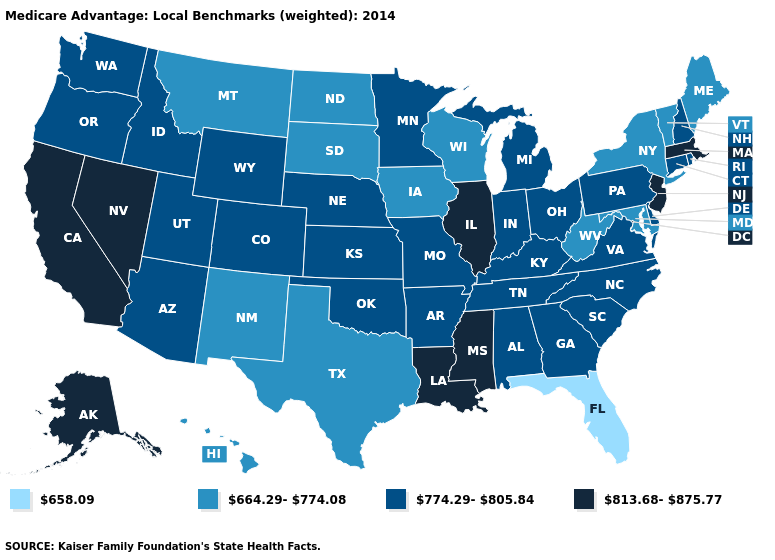Which states have the lowest value in the Northeast?
Write a very short answer. Maine, New York, Vermont. What is the value of Nevada?
Short answer required. 813.68-875.77. Which states have the lowest value in the USA?
Quick response, please. Florida. How many symbols are there in the legend?
Quick response, please. 4. What is the highest value in states that border New Mexico?
Short answer required. 774.29-805.84. What is the lowest value in states that border Tennessee?
Short answer required. 774.29-805.84. Does the map have missing data?
Keep it brief. No. Which states have the lowest value in the Northeast?
Short answer required. Maine, New York, Vermont. Name the states that have a value in the range 658.09?
Be succinct. Florida. What is the highest value in states that border Nevada?
Keep it brief. 813.68-875.77. Does Massachusetts have the lowest value in the Northeast?
Answer briefly. No. Does North Carolina have a lower value than Florida?
Keep it brief. No. Among the states that border Maryland , does Pennsylvania have the highest value?
Give a very brief answer. Yes. What is the value of Pennsylvania?
Write a very short answer. 774.29-805.84. 